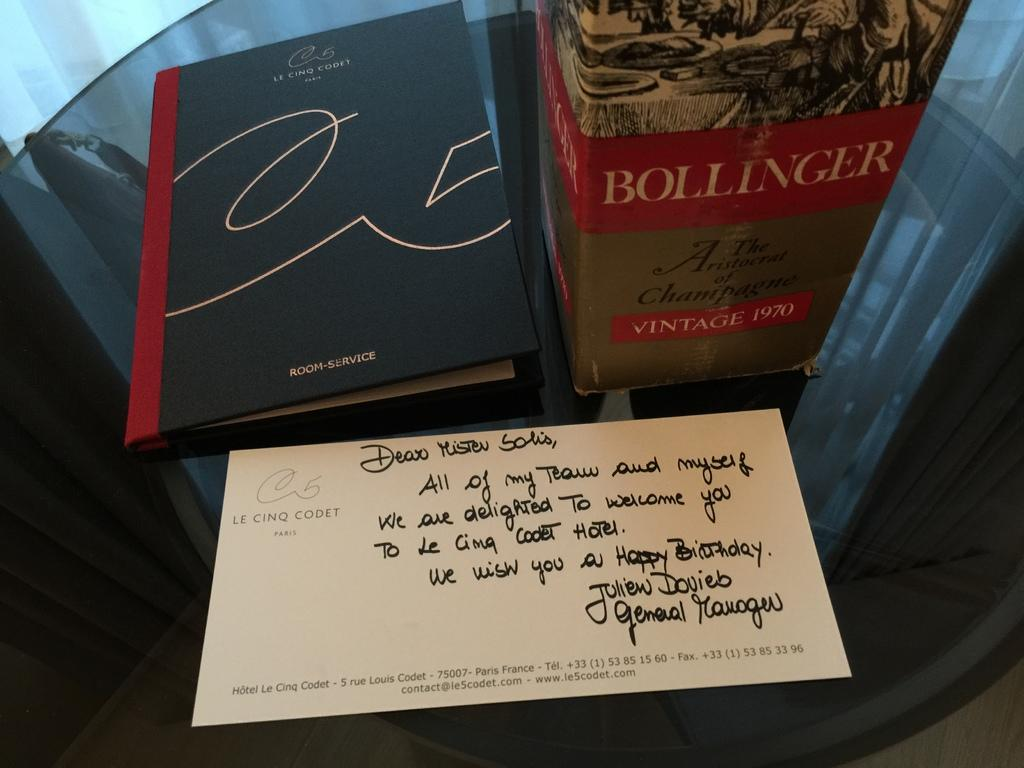<image>
Give a short and clear explanation of the subsequent image. A bottle of Bollinger champagne next to a room service menu from Le Cinq Codet 